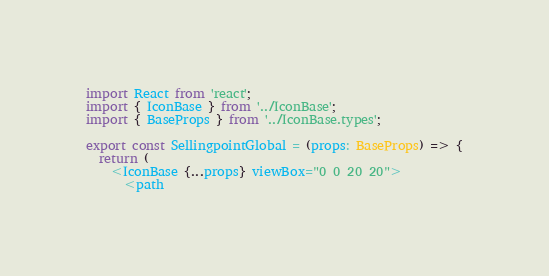Convert code to text. <code><loc_0><loc_0><loc_500><loc_500><_TypeScript_>import React from 'react';
import { IconBase } from '../IconBase';
import { BaseProps } from '../IconBase.types';

export const SellingpointGlobal = (props: BaseProps) => {
  return (
    <IconBase {...props} viewBox="0 0 20 20">
      <path</code> 